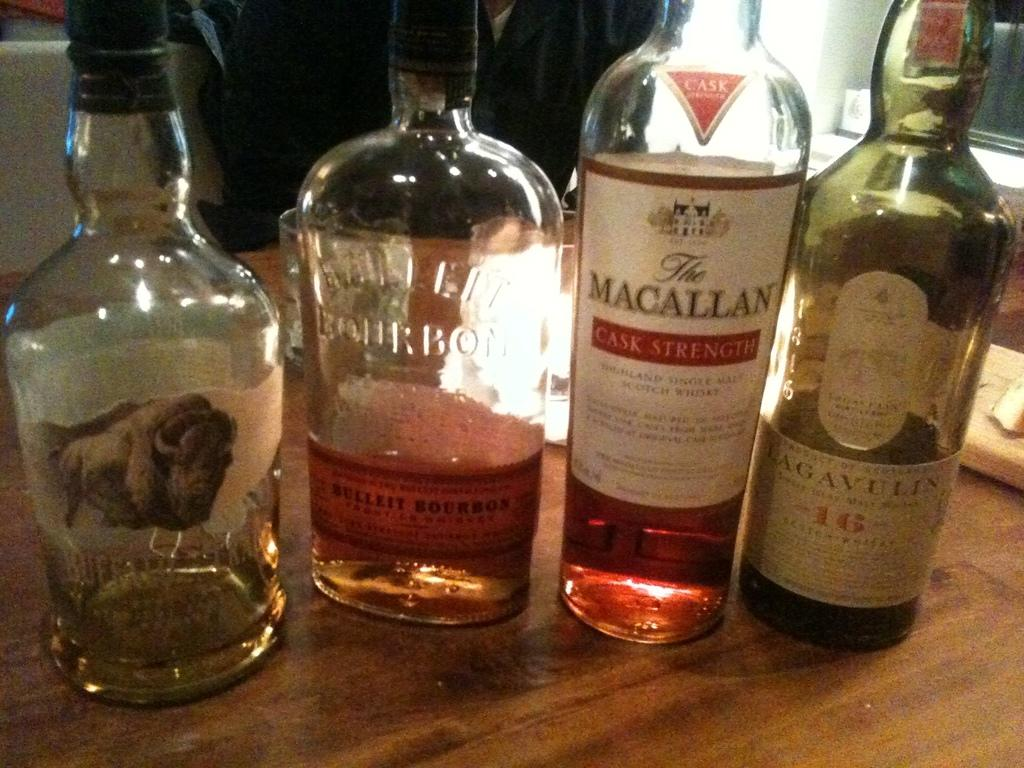<image>
Write a terse but informative summary of the picture. Various bottles of liquor with one of them a quarter of the way full stating it's a bourbon on the glass bottle. 